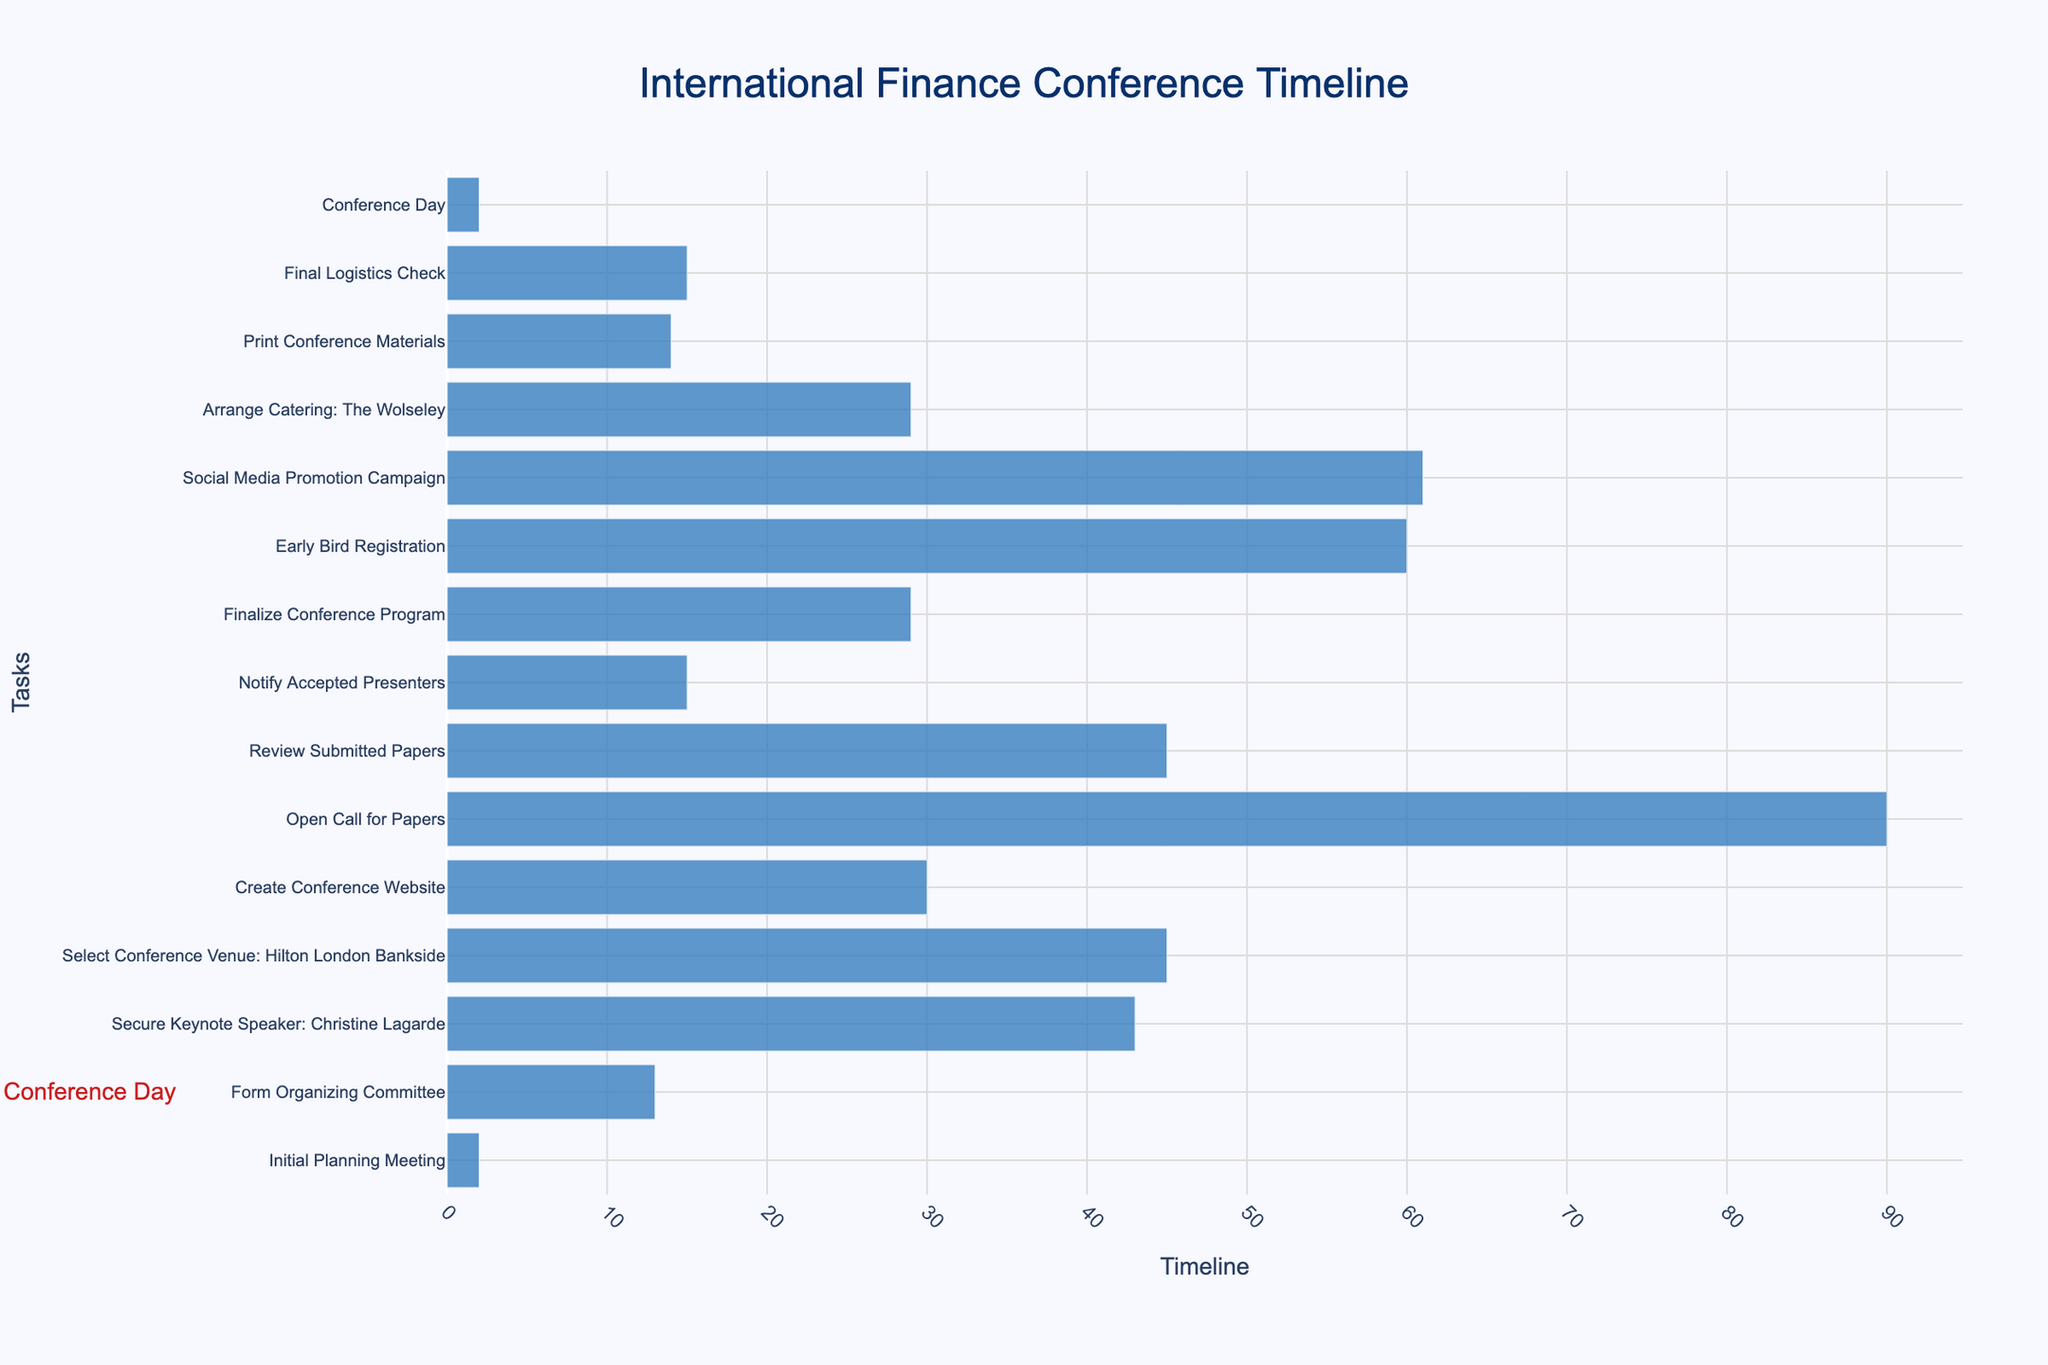When does the initial planning meeting start? The start date for the Initial Planning Meeting is displayed in the figure with a bar. The date is displayed as a hover text as well.
Answer: January 15, 2024 How long does it take to form the organizing committee? The task "Form Organizing Committee" has a start date of January 18, 2024, and an end date of January 31, 2024. The duration can be calculated by finding the difference between these dates.
Answer: 14 days Which task ends first in the timeline? By examining the end dates of all tasks, the task with the earliest end date is "Initial Planning Meeting", which ends on January 17, 2024.
Answer: Initial Planning Meeting How much time is allocated between the end of creating the conference website and the start of opening the call for papers? The end date for "Create Conference Website" is March 31, 2024, and the start date for "Open Call for Papers" is April 1, 2024. The difference between these dates is 1 day.
Answer: 1 day What is the duration of the social media promotion campaign? The task "Social Media Promotion Campaign" has a start date of October 15, 2024, and an end date of December 15, 2024. The duration is the difference between these dates.
Answer: 61 days Which two tasks occur concurrently between February and March 2024? Looking at the timeline, "Secure Keynote Speaker: Christine Lagarde" (February 1, 2024 - March 15, 2024) and "Select Conference Venue: Hilton London Bankside" (February 15, 2024 - March 31, 2024) overlap in February and March.
Answer: Secure Keynote Speaker: Christine Lagarde and Select Conference Venue: Hilton London Bankside Which task lasts the longest time? By comparing the durations of all tasks, "Open Call for Papers" has the longest duration, starting on April 1, 2024, and ending on June 30, 2024, which is 91 days.
Answer: Open Call for Papers Which tasks are finalized in November 2024? Within November 2024, "Early Bird Registration" and "Arrange Catering: The Wolseley" have end dates in this month. "Early Bird Registration" ends on November 30, 2024, and "Arrange Catering: The Wolseley" also ends on the same date.
Answer: Early Bird Registration and Arrange Catering: The Wolseley How much time is left between the final logistics check and the conference day? The "Final Logistics Check" ends on December 31, 2024. The "Conference Day" starts on January 15, 2025. The time left between these two dates is 15 days.
Answer: 15 days 